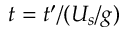<formula> <loc_0><loc_0><loc_500><loc_500>t = t ^ { \prime } / ( U _ { s } / g )</formula> 